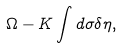<formula> <loc_0><loc_0><loc_500><loc_500>\Omega - K \int d \sigma \delta \eta ,</formula> 